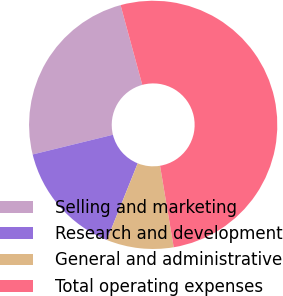Convert chart to OTSL. <chart><loc_0><loc_0><loc_500><loc_500><pie_chart><fcel>Selling and marketing<fcel>Research and development<fcel>General and administrative<fcel>Total operating expenses<nl><fcel>24.6%<fcel>15.08%<fcel>8.73%<fcel>51.59%<nl></chart> 